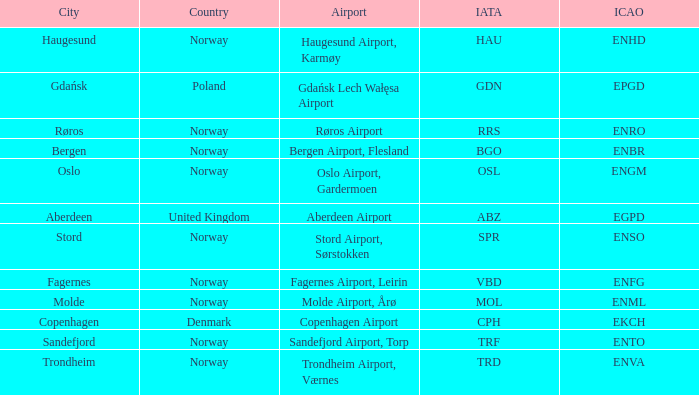What is th IATA for Norway with an ICAO of ENTO? TRF. 